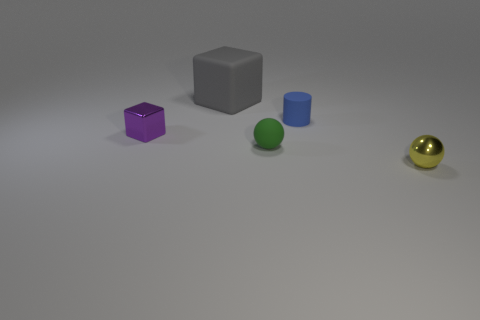Is the number of purple blocks in front of the matte block greater than the number of tiny cylinders in front of the small matte cylinder?
Provide a succinct answer. Yes. What number of yellow things are the same shape as the purple metal thing?
Your response must be concise. 0. There is a blue object that is the same size as the purple metallic thing; what is it made of?
Your answer should be compact. Rubber. Are there any big objects that have the same material as the tiny cylinder?
Offer a terse response. Yes. Is the number of tiny purple metallic blocks to the left of the tiny purple metallic block less than the number of blue rubber cylinders?
Provide a succinct answer. Yes. There is a tiny yellow thing right of the tiny shiny object that is left of the big gray object; what is it made of?
Make the answer very short. Metal. What shape is the tiny object that is both to the right of the green object and behind the yellow shiny ball?
Keep it short and to the point. Cylinder. What number of objects are small things that are on the left side of the blue matte thing or small matte objects?
Ensure brevity in your answer.  3. Are there any other things that are the same size as the gray block?
Provide a short and direct response. No. What size is the ball that is in front of the small rubber object that is left of the small blue matte cylinder?
Your response must be concise. Small. 